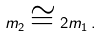Convert formula to latex. <formula><loc_0><loc_0><loc_500><loc_500>m _ { 2 } \cong 2 m _ { 1 } \, .</formula> 